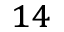Convert formula to latex. <formula><loc_0><loc_0><loc_500><loc_500>^ { 1 4 }</formula> 